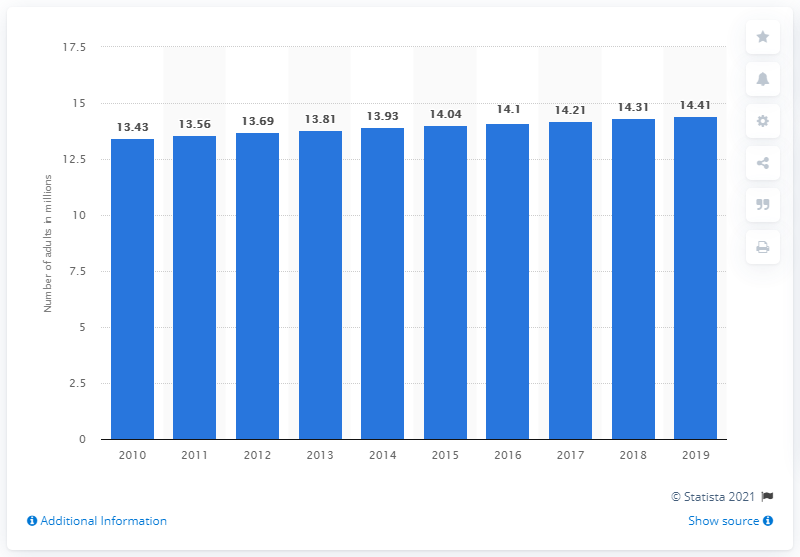Identify some key points in this picture. In 2019, there were 14,410,000 adults in Sri Lanka. 